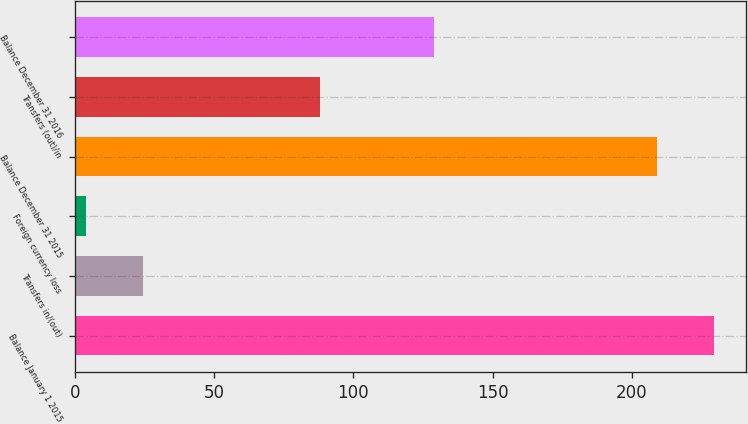Convert chart. <chart><loc_0><loc_0><loc_500><loc_500><bar_chart><fcel>Balance January 1 2015<fcel>Transfers in/(out)<fcel>Foreign currency loss<fcel>Balance December 31 2015<fcel>Transfers (out)/in<fcel>Balance December 31 2016<nl><fcel>229.6<fcel>24.6<fcel>4<fcel>209<fcel>88<fcel>129<nl></chart> 